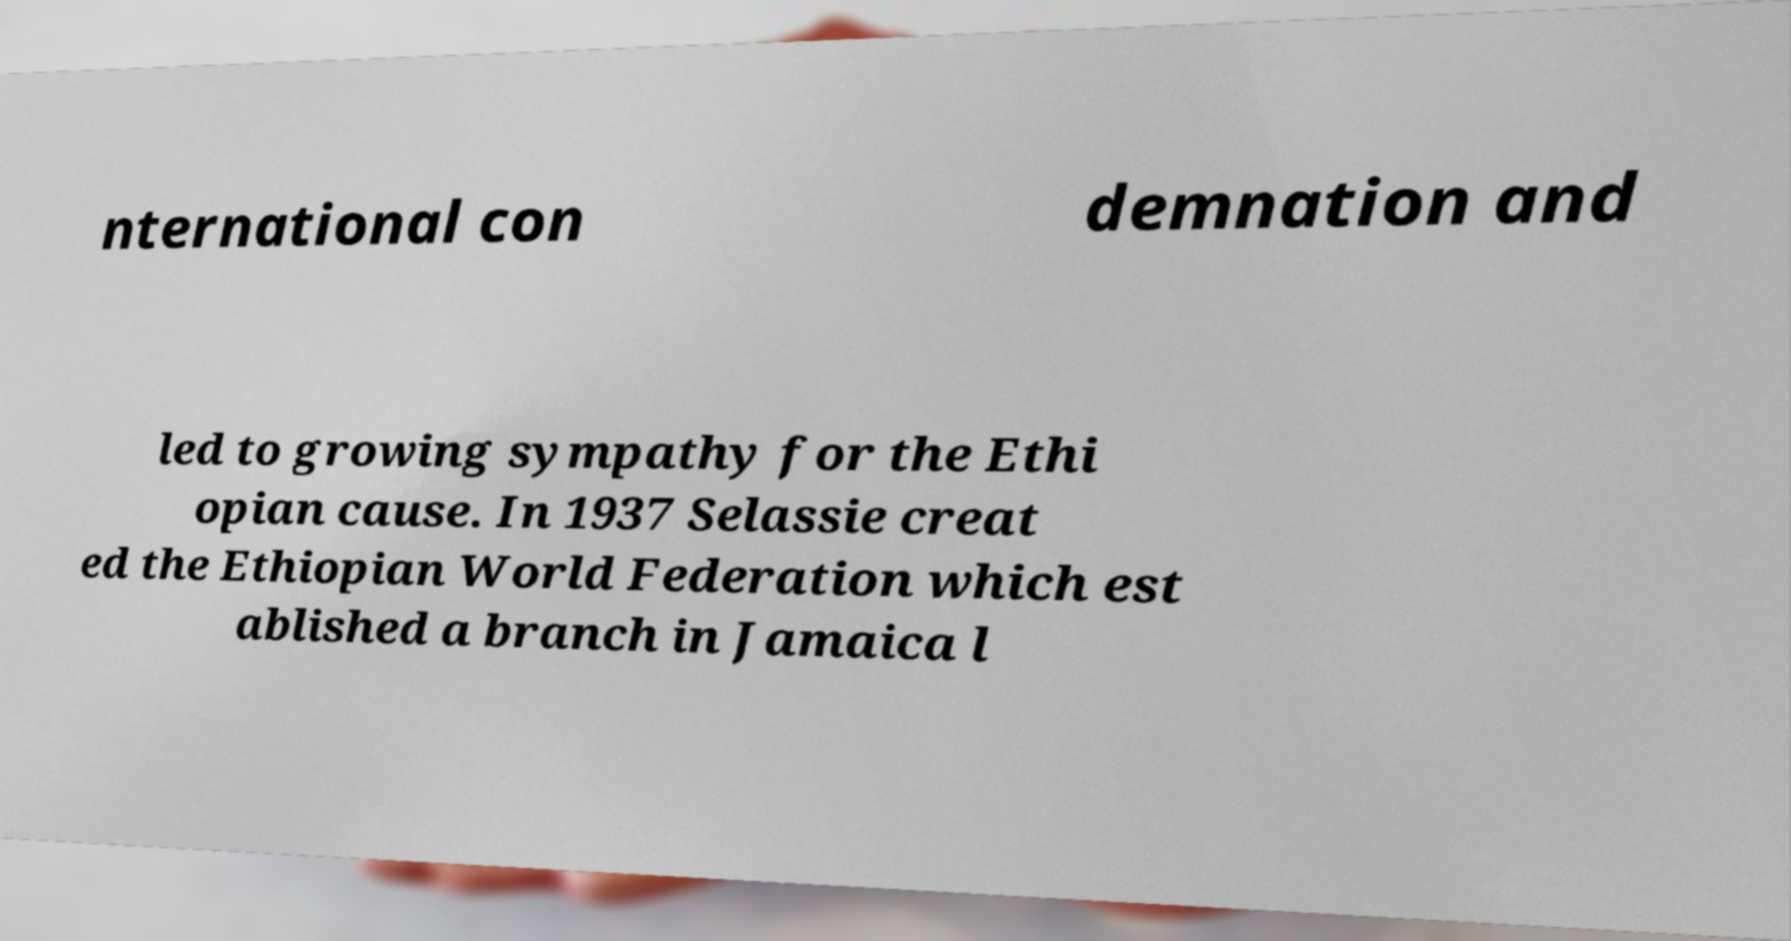I need the written content from this picture converted into text. Can you do that? nternational con demnation and led to growing sympathy for the Ethi opian cause. In 1937 Selassie creat ed the Ethiopian World Federation which est ablished a branch in Jamaica l 